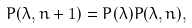<formula> <loc_0><loc_0><loc_500><loc_500>P ( \lambda , n + 1 ) = P ( \lambda ) P ( \lambda , n ) ,</formula> 